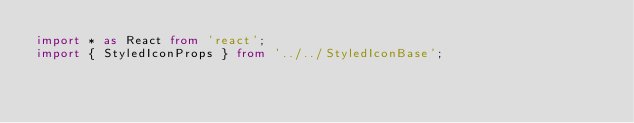<code> <loc_0><loc_0><loc_500><loc_500><_TypeScript_>import * as React from 'react';
import { StyledIconProps } from '../../StyledIconBase';</code> 